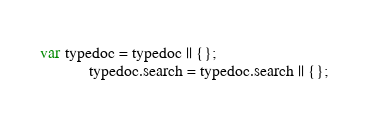Convert code to text. <code><loc_0><loc_0><loc_500><loc_500><_JavaScript_>var typedoc = typedoc || {};
            typedoc.search = typedoc.search || {};</code> 